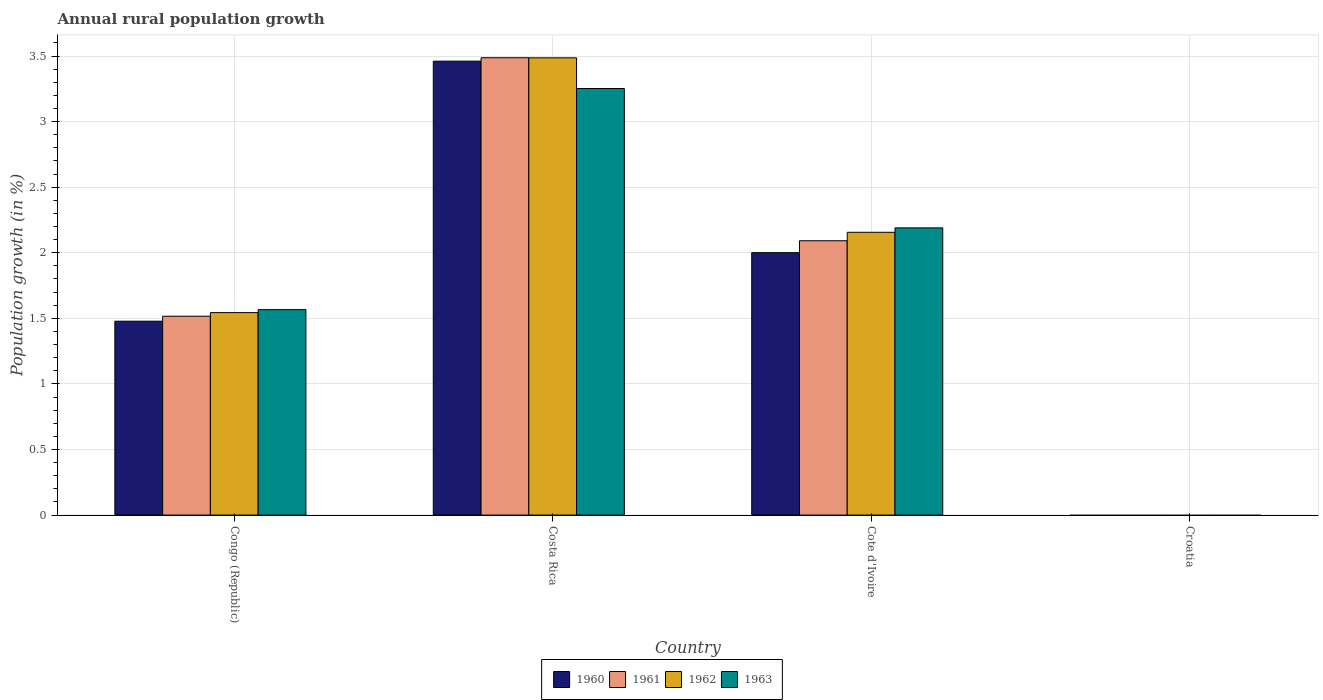Are the number of bars on each tick of the X-axis equal?
Make the answer very short. No. How many bars are there on the 4th tick from the right?
Your answer should be very brief. 4. What is the percentage of rural population growth in 1961 in Croatia?
Your answer should be very brief. 0. Across all countries, what is the maximum percentage of rural population growth in 1960?
Your answer should be compact. 3.46. Across all countries, what is the minimum percentage of rural population growth in 1962?
Keep it short and to the point. 0. What is the total percentage of rural population growth in 1963 in the graph?
Keep it short and to the point. 7.01. What is the difference between the percentage of rural population growth in 1961 in Congo (Republic) and that in Costa Rica?
Make the answer very short. -1.97. What is the difference between the percentage of rural population growth in 1963 in Congo (Republic) and the percentage of rural population growth in 1960 in Cote d'Ivoire?
Give a very brief answer. -0.43. What is the average percentage of rural population growth in 1961 per country?
Make the answer very short. 1.77. What is the difference between the percentage of rural population growth of/in 1961 and percentage of rural population growth of/in 1962 in Cote d'Ivoire?
Your response must be concise. -0.06. In how many countries, is the percentage of rural population growth in 1963 greater than 2.1 %?
Your response must be concise. 2. What is the ratio of the percentage of rural population growth in 1961 in Congo (Republic) to that in Costa Rica?
Your answer should be compact. 0.43. Is the percentage of rural population growth in 1961 in Congo (Republic) less than that in Costa Rica?
Keep it short and to the point. Yes. What is the difference between the highest and the second highest percentage of rural population growth in 1963?
Offer a very short reply. -0.62. What is the difference between the highest and the lowest percentage of rural population growth in 1962?
Keep it short and to the point. 3.49. In how many countries, is the percentage of rural population growth in 1961 greater than the average percentage of rural population growth in 1961 taken over all countries?
Provide a succinct answer. 2. Is it the case that in every country, the sum of the percentage of rural population growth in 1960 and percentage of rural population growth in 1962 is greater than the sum of percentage of rural population growth in 1963 and percentage of rural population growth in 1961?
Give a very brief answer. No. Is it the case that in every country, the sum of the percentage of rural population growth in 1961 and percentage of rural population growth in 1960 is greater than the percentage of rural population growth in 1963?
Ensure brevity in your answer.  No. How many bars are there?
Offer a terse response. 12. How many countries are there in the graph?
Give a very brief answer. 4. What is the difference between two consecutive major ticks on the Y-axis?
Provide a short and direct response. 0.5. Are the values on the major ticks of Y-axis written in scientific E-notation?
Your answer should be compact. No. Does the graph contain grids?
Offer a terse response. Yes. What is the title of the graph?
Provide a succinct answer. Annual rural population growth. What is the label or title of the Y-axis?
Offer a terse response. Population growth (in %). What is the Population growth (in %) in 1960 in Congo (Republic)?
Your answer should be compact. 1.48. What is the Population growth (in %) in 1961 in Congo (Republic)?
Your answer should be very brief. 1.52. What is the Population growth (in %) in 1962 in Congo (Republic)?
Offer a very short reply. 1.54. What is the Population growth (in %) of 1963 in Congo (Republic)?
Your answer should be very brief. 1.57. What is the Population growth (in %) in 1960 in Costa Rica?
Give a very brief answer. 3.46. What is the Population growth (in %) in 1961 in Costa Rica?
Offer a very short reply. 3.49. What is the Population growth (in %) of 1962 in Costa Rica?
Your response must be concise. 3.49. What is the Population growth (in %) of 1963 in Costa Rica?
Offer a very short reply. 3.25. What is the Population growth (in %) in 1960 in Cote d'Ivoire?
Keep it short and to the point. 2. What is the Population growth (in %) of 1961 in Cote d'Ivoire?
Your answer should be very brief. 2.09. What is the Population growth (in %) of 1962 in Cote d'Ivoire?
Provide a short and direct response. 2.16. What is the Population growth (in %) in 1963 in Cote d'Ivoire?
Give a very brief answer. 2.19. What is the Population growth (in %) in 1960 in Croatia?
Give a very brief answer. 0. What is the Population growth (in %) of 1963 in Croatia?
Give a very brief answer. 0. Across all countries, what is the maximum Population growth (in %) in 1960?
Offer a very short reply. 3.46. Across all countries, what is the maximum Population growth (in %) in 1961?
Offer a very short reply. 3.49. Across all countries, what is the maximum Population growth (in %) in 1962?
Provide a short and direct response. 3.49. Across all countries, what is the maximum Population growth (in %) in 1963?
Your answer should be very brief. 3.25. Across all countries, what is the minimum Population growth (in %) of 1960?
Offer a terse response. 0. Across all countries, what is the minimum Population growth (in %) of 1962?
Your answer should be compact. 0. What is the total Population growth (in %) in 1960 in the graph?
Offer a very short reply. 6.94. What is the total Population growth (in %) in 1961 in the graph?
Provide a succinct answer. 7.09. What is the total Population growth (in %) of 1962 in the graph?
Your answer should be compact. 7.19. What is the total Population growth (in %) in 1963 in the graph?
Your response must be concise. 7.01. What is the difference between the Population growth (in %) of 1960 in Congo (Republic) and that in Costa Rica?
Ensure brevity in your answer.  -1.98. What is the difference between the Population growth (in %) in 1961 in Congo (Republic) and that in Costa Rica?
Give a very brief answer. -1.97. What is the difference between the Population growth (in %) of 1962 in Congo (Republic) and that in Costa Rica?
Your answer should be very brief. -1.94. What is the difference between the Population growth (in %) of 1963 in Congo (Republic) and that in Costa Rica?
Your response must be concise. -1.69. What is the difference between the Population growth (in %) of 1960 in Congo (Republic) and that in Cote d'Ivoire?
Your response must be concise. -0.52. What is the difference between the Population growth (in %) in 1961 in Congo (Republic) and that in Cote d'Ivoire?
Provide a short and direct response. -0.58. What is the difference between the Population growth (in %) in 1962 in Congo (Republic) and that in Cote d'Ivoire?
Offer a very short reply. -0.61. What is the difference between the Population growth (in %) in 1963 in Congo (Republic) and that in Cote d'Ivoire?
Provide a short and direct response. -0.62. What is the difference between the Population growth (in %) of 1960 in Costa Rica and that in Cote d'Ivoire?
Provide a succinct answer. 1.46. What is the difference between the Population growth (in %) of 1961 in Costa Rica and that in Cote d'Ivoire?
Offer a terse response. 1.4. What is the difference between the Population growth (in %) of 1962 in Costa Rica and that in Cote d'Ivoire?
Offer a terse response. 1.33. What is the difference between the Population growth (in %) of 1963 in Costa Rica and that in Cote d'Ivoire?
Give a very brief answer. 1.06. What is the difference between the Population growth (in %) in 1960 in Congo (Republic) and the Population growth (in %) in 1961 in Costa Rica?
Keep it short and to the point. -2.01. What is the difference between the Population growth (in %) in 1960 in Congo (Republic) and the Population growth (in %) in 1962 in Costa Rica?
Offer a terse response. -2.01. What is the difference between the Population growth (in %) of 1960 in Congo (Republic) and the Population growth (in %) of 1963 in Costa Rica?
Offer a terse response. -1.77. What is the difference between the Population growth (in %) of 1961 in Congo (Republic) and the Population growth (in %) of 1962 in Costa Rica?
Your answer should be compact. -1.97. What is the difference between the Population growth (in %) in 1961 in Congo (Republic) and the Population growth (in %) in 1963 in Costa Rica?
Your answer should be very brief. -1.74. What is the difference between the Population growth (in %) in 1962 in Congo (Republic) and the Population growth (in %) in 1963 in Costa Rica?
Keep it short and to the point. -1.71. What is the difference between the Population growth (in %) of 1960 in Congo (Republic) and the Population growth (in %) of 1961 in Cote d'Ivoire?
Keep it short and to the point. -0.61. What is the difference between the Population growth (in %) of 1960 in Congo (Republic) and the Population growth (in %) of 1962 in Cote d'Ivoire?
Offer a terse response. -0.68. What is the difference between the Population growth (in %) of 1960 in Congo (Republic) and the Population growth (in %) of 1963 in Cote d'Ivoire?
Make the answer very short. -0.71. What is the difference between the Population growth (in %) in 1961 in Congo (Republic) and the Population growth (in %) in 1962 in Cote d'Ivoire?
Your answer should be compact. -0.64. What is the difference between the Population growth (in %) of 1961 in Congo (Republic) and the Population growth (in %) of 1963 in Cote d'Ivoire?
Your response must be concise. -0.67. What is the difference between the Population growth (in %) of 1962 in Congo (Republic) and the Population growth (in %) of 1963 in Cote d'Ivoire?
Keep it short and to the point. -0.65. What is the difference between the Population growth (in %) in 1960 in Costa Rica and the Population growth (in %) in 1961 in Cote d'Ivoire?
Offer a terse response. 1.37. What is the difference between the Population growth (in %) of 1960 in Costa Rica and the Population growth (in %) of 1962 in Cote d'Ivoire?
Your response must be concise. 1.3. What is the difference between the Population growth (in %) of 1960 in Costa Rica and the Population growth (in %) of 1963 in Cote d'Ivoire?
Ensure brevity in your answer.  1.27. What is the difference between the Population growth (in %) of 1961 in Costa Rica and the Population growth (in %) of 1962 in Cote d'Ivoire?
Make the answer very short. 1.33. What is the difference between the Population growth (in %) of 1961 in Costa Rica and the Population growth (in %) of 1963 in Cote d'Ivoire?
Provide a short and direct response. 1.3. What is the difference between the Population growth (in %) in 1962 in Costa Rica and the Population growth (in %) in 1963 in Cote d'Ivoire?
Offer a very short reply. 1.3. What is the average Population growth (in %) in 1960 per country?
Your answer should be very brief. 1.73. What is the average Population growth (in %) of 1961 per country?
Provide a succinct answer. 1.77. What is the average Population growth (in %) in 1962 per country?
Provide a succinct answer. 1.8. What is the average Population growth (in %) in 1963 per country?
Your answer should be compact. 1.75. What is the difference between the Population growth (in %) in 1960 and Population growth (in %) in 1961 in Congo (Republic)?
Ensure brevity in your answer.  -0.04. What is the difference between the Population growth (in %) in 1960 and Population growth (in %) in 1962 in Congo (Republic)?
Give a very brief answer. -0.07. What is the difference between the Population growth (in %) in 1960 and Population growth (in %) in 1963 in Congo (Republic)?
Give a very brief answer. -0.09. What is the difference between the Population growth (in %) of 1961 and Population growth (in %) of 1962 in Congo (Republic)?
Keep it short and to the point. -0.03. What is the difference between the Population growth (in %) in 1961 and Population growth (in %) in 1963 in Congo (Republic)?
Your response must be concise. -0.05. What is the difference between the Population growth (in %) of 1962 and Population growth (in %) of 1963 in Congo (Republic)?
Keep it short and to the point. -0.02. What is the difference between the Population growth (in %) in 1960 and Population growth (in %) in 1961 in Costa Rica?
Your answer should be compact. -0.03. What is the difference between the Population growth (in %) in 1960 and Population growth (in %) in 1962 in Costa Rica?
Offer a terse response. -0.03. What is the difference between the Population growth (in %) of 1960 and Population growth (in %) of 1963 in Costa Rica?
Make the answer very short. 0.21. What is the difference between the Population growth (in %) of 1961 and Population growth (in %) of 1962 in Costa Rica?
Your answer should be compact. 0. What is the difference between the Population growth (in %) in 1961 and Population growth (in %) in 1963 in Costa Rica?
Your answer should be compact. 0.23. What is the difference between the Population growth (in %) in 1962 and Population growth (in %) in 1963 in Costa Rica?
Provide a succinct answer. 0.23. What is the difference between the Population growth (in %) of 1960 and Population growth (in %) of 1961 in Cote d'Ivoire?
Keep it short and to the point. -0.09. What is the difference between the Population growth (in %) in 1960 and Population growth (in %) in 1962 in Cote d'Ivoire?
Provide a succinct answer. -0.16. What is the difference between the Population growth (in %) of 1960 and Population growth (in %) of 1963 in Cote d'Ivoire?
Provide a succinct answer. -0.19. What is the difference between the Population growth (in %) in 1961 and Population growth (in %) in 1962 in Cote d'Ivoire?
Your answer should be very brief. -0.06. What is the difference between the Population growth (in %) in 1961 and Population growth (in %) in 1963 in Cote d'Ivoire?
Your response must be concise. -0.1. What is the difference between the Population growth (in %) of 1962 and Population growth (in %) of 1963 in Cote d'Ivoire?
Ensure brevity in your answer.  -0.03. What is the ratio of the Population growth (in %) in 1960 in Congo (Republic) to that in Costa Rica?
Offer a very short reply. 0.43. What is the ratio of the Population growth (in %) in 1961 in Congo (Republic) to that in Costa Rica?
Offer a terse response. 0.43. What is the ratio of the Population growth (in %) of 1962 in Congo (Republic) to that in Costa Rica?
Offer a very short reply. 0.44. What is the ratio of the Population growth (in %) in 1963 in Congo (Republic) to that in Costa Rica?
Provide a short and direct response. 0.48. What is the ratio of the Population growth (in %) in 1960 in Congo (Republic) to that in Cote d'Ivoire?
Your response must be concise. 0.74. What is the ratio of the Population growth (in %) of 1961 in Congo (Republic) to that in Cote d'Ivoire?
Ensure brevity in your answer.  0.72. What is the ratio of the Population growth (in %) in 1962 in Congo (Republic) to that in Cote d'Ivoire?
Ensure brevity in your answer.  0.72. What is the ratio of the Population growth (in %) of 1963 in Congo (Republic) to that in Cote d'Ivoire?
Ensure brevity in your answer.  0.72. What is the ratio of the Population growth (in %) of 1960 in Costa Rica to that in Cote d'Ivoire?
Offer a very short reply. 1.73. What is the ratio of the Population growth (in %) of 1961 in Costa Rica to that in Cote d'Ivoire?
Keep it short and to the point. 1.67. What is the ratio of the Population growth (in %) in 1962 in Costa Rica to that in Cote d'Ivoire?
Offer a terse response. 1.62. What is the ratio of the Population growth (in %) of 1963 in Costa Rica to that in Cote d'Ivoire?
Keep it short and to the point. 1.49. What is the difference between the highest and the second highest Population growth (in %) in 1960?
Keep it short and to the point. 1.46. What is the difference between the highest and the second highest Population growth (in %) in 1961?
Keep it short and to the point. 1.4. What is the difference between the highest and the second highest Population growth (in %) of 1962?
Your answer should be compact. 1.33. What is the difference between the highest and the second highest Population growth (in %) in 1963?
Your answer should be very brief. 1.06. What is the difference between the highest and the lowest Population growth (in %) of 1960?
Provide a succinct answer. 3.46. What is the difference between the highest and the lowest Population growth (in %) in 1961?
Your response must be concise. 3.49. What is the difference between the highest and the lowest Population growth (in %) of 1962?
Ensure brevity in your answer.  3.49. What is the difference between the highest and the lowest Population growth (in %) of 1963?
Give a very brief answer. 3.25. 